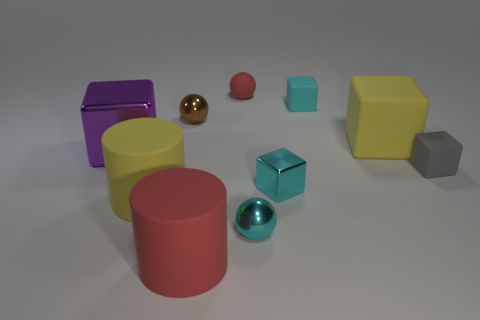Subtract all yellow blocks. How many blocks are left? 4 Subtract all yellow rubber blocks. How many blocks are left? 4 Subtract all green cubes. Subtract all brown spheres. How many cubes are left? 5 Subtract all cylinders. How many objects are left? 8 Add 1 cyan metallic balls. How many cyan metallic balls are left? 2 Add 1 purple balls. How many purple balls exist? 1 Subtract 1 red cylinders. How many objects are left? 9 Subtract all small brown shiny balls. Subtract all tiny red things. How many objects are left? 8 